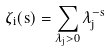Convert formula to latex. <formula><loc_0><loc_0><loc_500><loc_500>\zeta _ { i } ( s ) = \sum _ { \lambda _ { j } > 0 } \lambda _ { j } ^ { - s }</formula> 